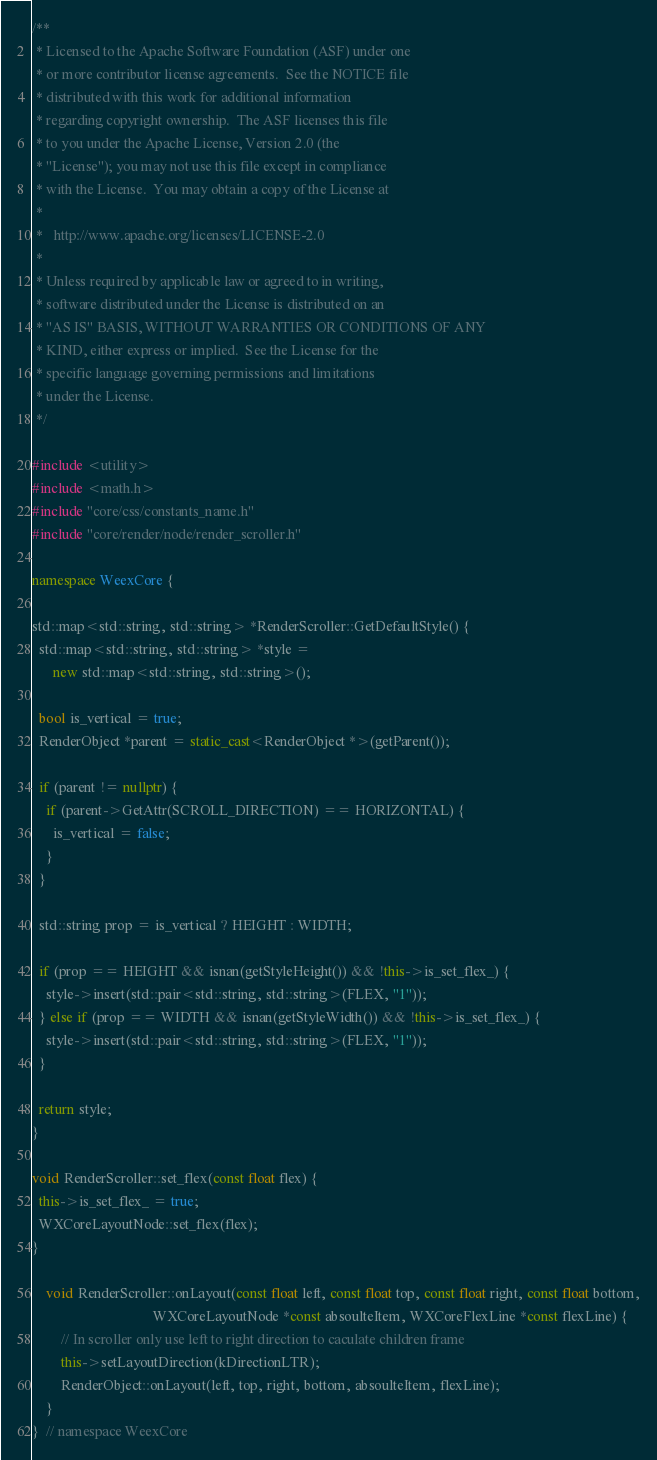Convert code to text. <code><loc_0><loc_0><loc_500><loc_500><_C++_>/**
 * Licensed to the Apache Software Foundation (ASF) under one
 * or more contributor license agreements.  See the NOTICE file
 * distributed with this work for additional information
 * regarding copyright ownership.  The ASF licenses this file
 * to you under the Apache License, Version 2.0 (the
 * "License"); you may not use this file except in compliance
 * with the License.  You may obtain a copy of the License at
 *
 *   http://www.apache.org/licenses/LICENSE-2.0
 *
 * Unless required by applicable law or agreed to in writing,
 * software distributed under the License is distributed on an
 * "AS IS" BASIS, WITHOUT WARRANTIES OR CONDITIONS OF ANY
 * KIND, either express or implied.  See the License for the
 * specific language governing permissions and limitations
 * under the License.
 */

#include <utility>
#include <math.h>
#include "core/css/constants_name.h"
#include "core/render/node/render_scroller.h"

namespace WeexCore {

std::map<std::string, std::string> *RenderScroller::GetDefaultStyle() {
  std::map<std::string, std::string> *style =
      new std::map<std::string, std::string>();

  bool is_vertical = true;
  RenderObject *parent = static_cast<RenderObject *>(getParent());

  if (parent != nullptr) {
    if (parent->GetAttr(SCROLL_DIRECTION) == HORIZONTAL) {
      is_vertical = false;
    }
  }

  std::string prop = is_vertical ? HEIGHT : WIDTH;

  if (prop == HEIGHT && isnan(getStyleHeight()) && !this->is_set_flex_) {
    style->insert(std::pair<std::string, std::string>(FLEX, "1"));
  } else if (prop == WIDTH && isnan(getStyleWidth()) && !this->is_set_flex_) {
    style->insert(std::pair<std::string, std::string>(FLEX, "1"));
  }

  return style;
}

void RenderScroller::set_flex(const float flex) {
  this->is_set_flex_ = true;
  WXCoreLayoutNode::set_flex(flex);
}
    
    void RenderScroller::onLayout(const float left, const float top, const float right, const float bottom,
                                  WXCoreLayoutNode *const absoulteItem, WXCoreFlexLine *const flexLine) {
        // In scroller only use left to right direction to caculate children frame
        this->setLayoutDirection(kDirectionLTR);
        RenderObject::onLayout(left, top, right, bottom, absoulteItem, flexLine);
    }
}  // namespace WeexCore
</code> 